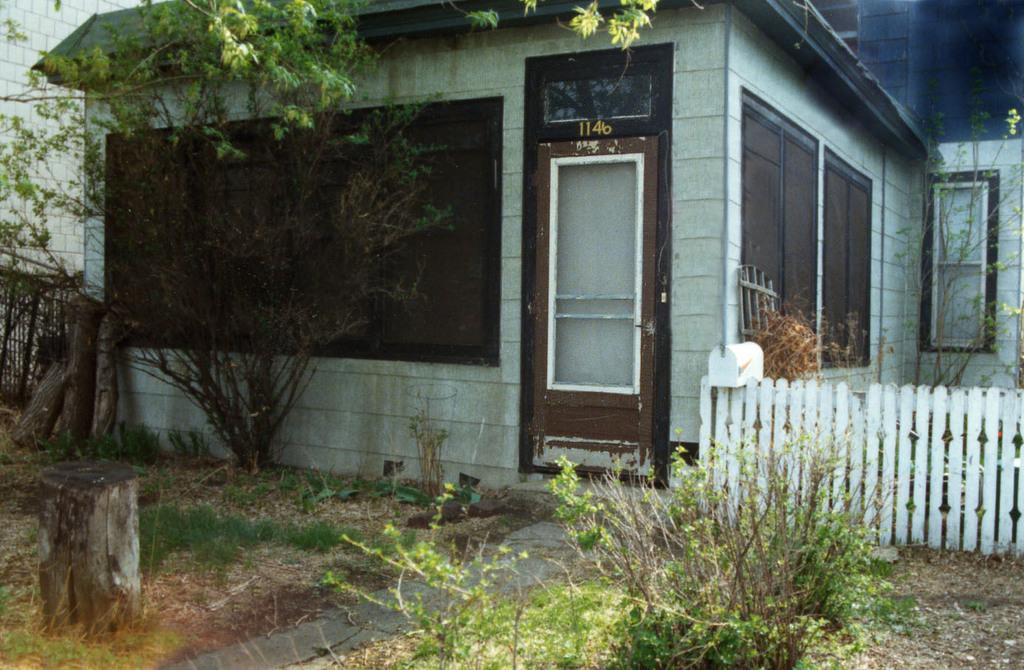Describe this image in one or two sentences. The picture is taken outside a house. In the foreground of the picture there are plants, dry leaves, grass and wood log. In the center of the picture there are trees, railing, house, door and windows. On the left there is a brick wall. 